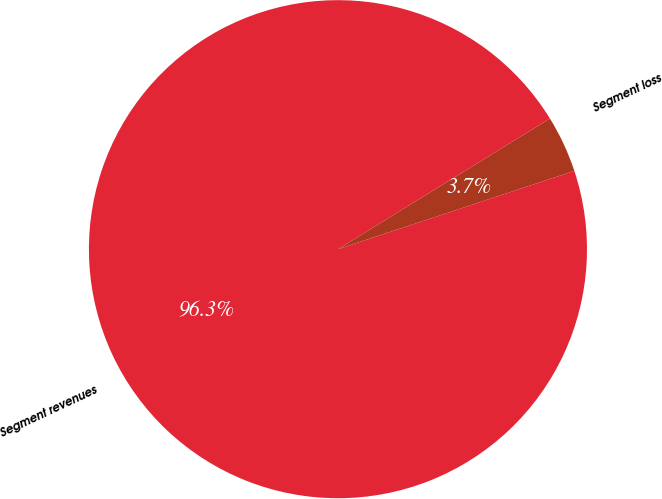Convert chart to OTSL. <chart><loc_0><loc_0><loc_500><loc_500><pie_chart><fcel>Segment revenues<fcel>Segment loss<nl><fcel>96.3%<fcel>3.7%<nl></chart> 